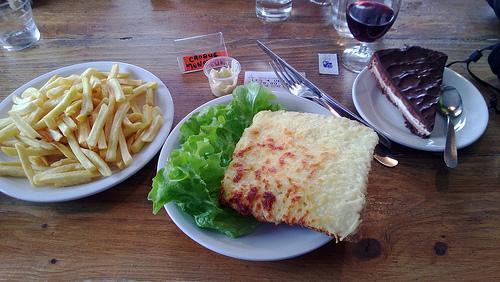How many plates of food?
Give a very brief answer. 3. 